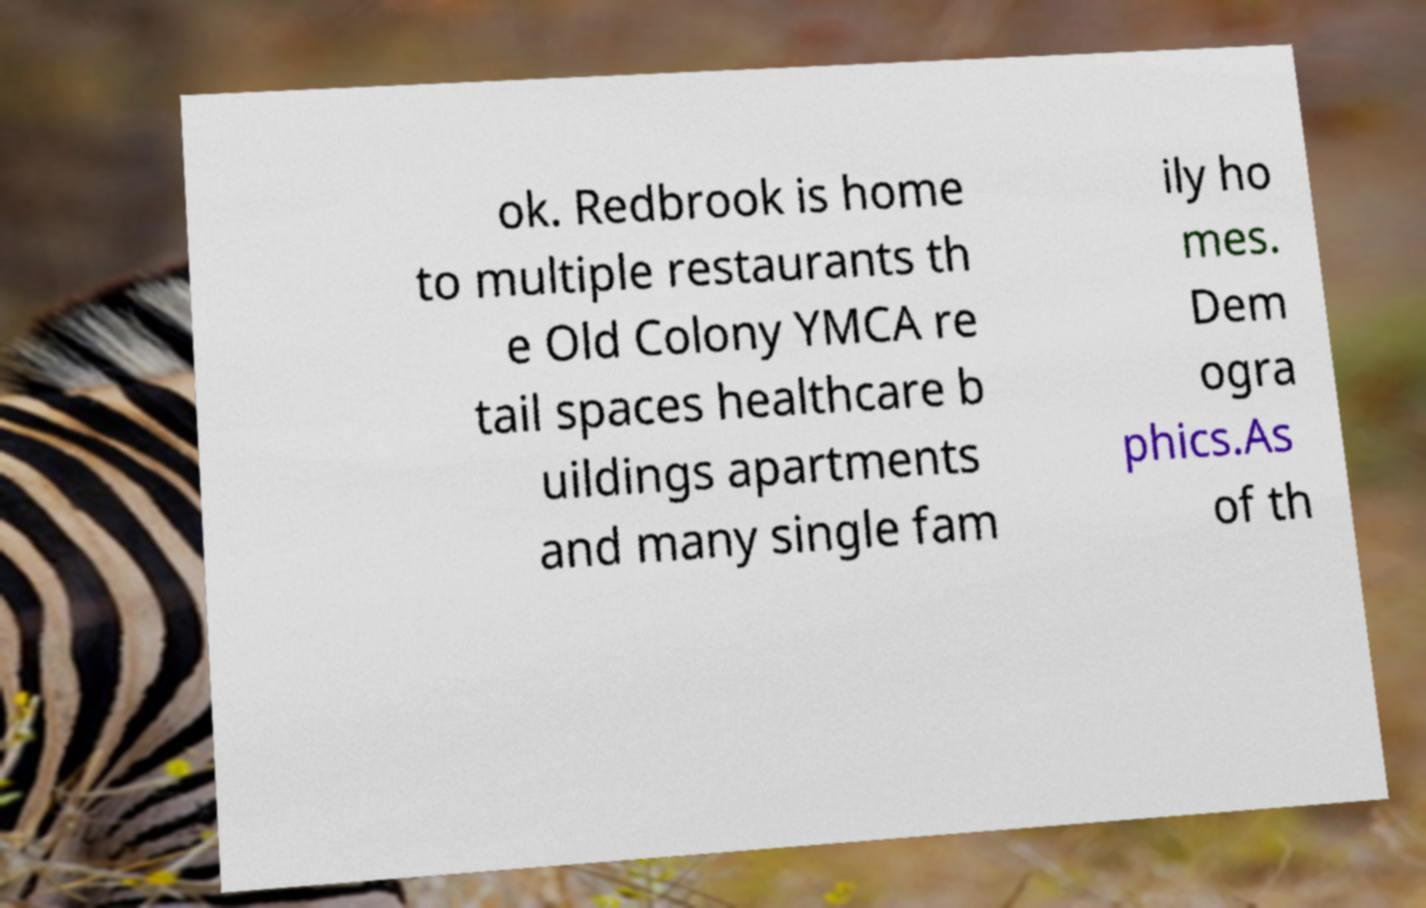Could you assist in decoding the text presented in this image and type it out clearly? ok. Redbrook is home to multiple restaurants th e Old Colony YMCA re tail spaces healthcare b uildings apartments and many single fam ily ho mes. Dem ogra phics.As of th 